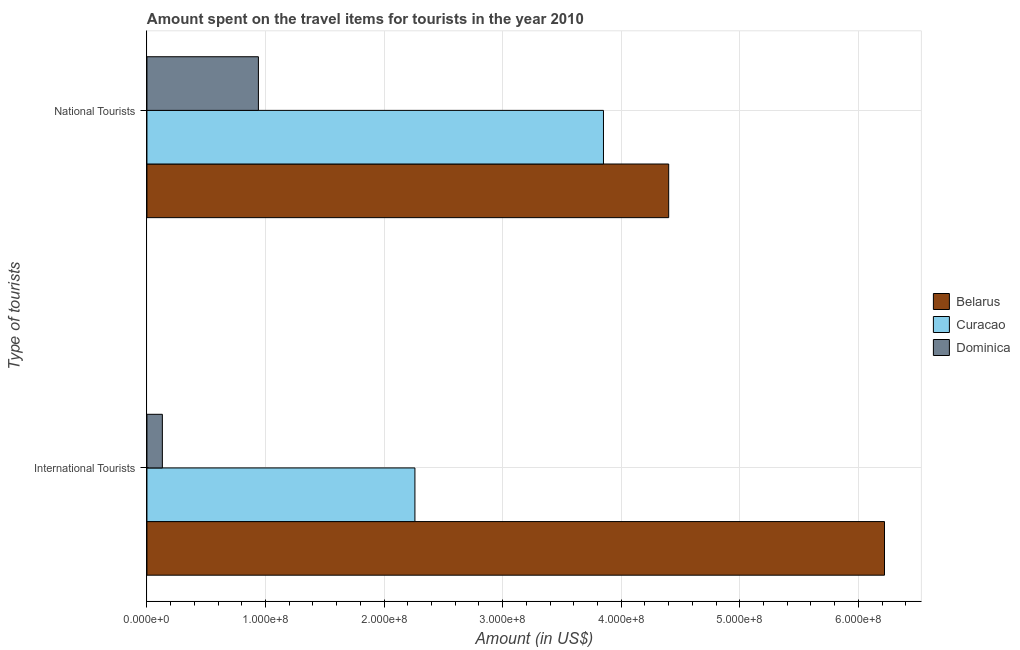Are the number of bars per tick equal to the number of legend labels?
Your answer should be compact. Yes. How many bars are there on the 2nd tick from the top?
Your answer should be very brief. 3. How many bars are there on the 2nd tick from the bottom?
Make the answer very short. 3. What is the label of the 2nd group of bars from the top?
Your answer should be compact. International Tourists. What is the amount spent on travel items of international tourists in Dominica?
Keep it short and to the point. 1.30e+07. Across all countries, what is the maximum amount spent on travel items of international tourists?
Provide a succinct answer. 6.22e+08. Across all countries, what is the minimum amount spent on travel items of national tourists?
Offer a very short reply. 9.40e+07. In which country was the amount spent on travel items of national tourists maximum?
Offer a terse response. Belarus. In which country was the amount spent on travel items of international tourists minimum?
Keep it short and to the point. Dominica. What is the total amount spent on travel items of national tourists in the graph?
Make the answer very short. 9.19e+08. What is the difference between the amount spent on travel items of national tourists in Curacao and that in Dominica?
Offer a very short reply. 2.91e+08. What is the difference between the amount spent on travel items of international tourists in Belarus and the amount spent on travel items of national tourists in Curacao?
Make the answer very short. 2.37e+08. What is the average amount spent on travel items of national tourists per country?
Ensure brevity in your answer.  3.06e+08. What is the difference between the amount spent on travel items of national tourists and amount spent on travel items of international tourists in Belarus?
Give a very brief answer. -1.82e+08. What is the ratio of the amount spent on travel items of international tourists in Dominica to that in Curacao?
Keep it short and to the point. 0.06. Is the amount spent on travel items of international tourists in Dominica less than that in Belarus?
Make the answer very short. Yes. In how many countries, is the amount spent on travel items of international tourists greater than the average amount spent on travel items of international tourists taken over all countries?
Offer a terse response. 1. What does the 1st bar from the top in National Tourists represents?
Offer a terse response. Dominica. What does the 1st bar from the bottom in National Tourists represents?
Give a very brief answer. Belarus. What is the difference between two consecutive major ticks on the X-axis?
Keep it short and to the point. 1.00e+08. Does the graph contain any zero values?
Your answer should be very brief. No. Does the graph contain grids?
Offer a very short reply. Yes. How are the legend labels stacked?
Give a very brief answer. Vertical. What is the title of the graph?
Ensure brevity in your answer.  Amount spent on the travel items for tourists in the year 2010. What is the label or title of the Y-axis?
Provide a succinct answer. Type of tourists. What is the Amount (in US$) in Belarus in International Tourists?
Your response must be concise. 6.22e+08. What is the Amount (in US$) of Curacao in International Tourists?
Your answer should be very brief. 2.26e+08. What is the Amount (in US$) in Dominica in International Tourists?
Your response must be concise. 1.30e+07. What is the Amount (in US$) in Belarus in National Tourists?
Provide a succinct answer. 4.40e+08. What is the Amount (in US$) of Curacao in National Tourists?
Make the answer very short. 3.85e+08. What is the Amount (in US$) in Dominica in National Tourists?
Your response must be concise. 9.40e+07. Across all Type of tourists, what is the maximum Amount (in US$) in Belarus?
Keep it short and to the point. 6.22e+08. Across all Type of tourists, what is the maximum Amount (in US$) in Curacao?
Your answer should be very brief. 3.85e+08. Across all Type of tourists, what is the maximum Amount (in US$) of Dominica?
Offer a very short reply. 9.40e+07. Across all Type of tourists, what is the minimum Amount (in US$) of Belarus?
Your answer should be compact. 4.40e+08. Across all Type of tourists, what is the minimum Amount (in US$) in Curacao?
Offer a terse response. 2.26e+08. Across all Type of tourists, what is the minimum Amount (in US$) of Dominica?
Ensure brevity in your answer.  1.30e+07. What is the total Amount (in US$) in Belarus in the graph?
Provide a short and direct response. 1.06e+09. What is the total Amount (in US$) in Curacao in the graph?
Keep it short and to the point. 6.11e+08. What is the total Amount (in US$) of Dominica in the graph?
Your answer should be very brief. 1.07e+08. What is the difference between the Amount (in US$) of Belarus in International Tourists and that in National Tourists?
Give a very brief answer. 1.82e+08. What is the difference between the Amount (in US$) of Curacao in International Tourists and that in National Tourists?
Offer a terse response. -1.59e+08. What is the difference between the Amount (in US$) in Dominica in International Tourists and that in National Tourists?
Give a very brief answer. -8.10e+07. What is the difference between the Amount (in US$) of Belarus in International Tourists and the Amount (in US$) of Curacao in National Tourists?
Ensure brevity in your answer.  2.37e+08. What is the difference between the Amount (in US$) of Belarus in International Tourists and the Amount (in US$) of Dominica in National Tourists?
Keep it short and to the point. 5.28e+08. What is the difference between the Amount (in US$) of Curacao in International Tourists and the Amount (in US$) of Dominica in National Tourists?
Provide a succinct answer. 1.32e+08. What is the average Amount (in US$) of Belarus per Type of tourists?
Your answer should be very brief. 5.31e+08. What is the average Amount (in US$) of Curacao per Type of tourists?
Provide a succinct answer. 3.06e+08. What is the average Amount (in US$) of Dominica per Type of tourists?
Give a very brief answer. 5.35e+07. What is the difference between the Amount (in US$) of Belarus and Amount (in US$) of Curacao in International Tourists?
Your answer should be very brief. 3.96e+08. What is the difference between the Amount (in US$) of Belarus and Amount (in US$) of Dominica in International Tourists?
Ensure brevity in your answer.  6.09e+08. What is the difference between the Amount (in US$) of Curacao and Amount (in US$) of Dominica in International Tourists?
Your answer should be very brief. 2.13e+08. What is the difference between the Amount (in US$) of Belarus and Amount (in US$) of Curacao in National Tourists?
Offer a very short reply. 5.50e+07. What is the difference between the Amount (in US$) in Belarus and Amount (in US$) in Dominica in National Tourists?
Make the answer very short. 3.46e+08. What is the difference between the Amount (in US$) in Curacao and Amount (in US$) in Dominica in National Tourists?
Your answer should be very brief. 2.91e+08. What is the ratio of the Amount (in US$) of Belarus in International Tourists to that in National Tourists?
Provide a short and direct response. 1.41. What is the ratio of the Amount (in US$) in Curacao in International Tourists to that in National Tourists?
Give a very brief answer. 0.59. What is the ratio of the Amount (in US$) in Dominica in International Tourists to that in National Tourists?
Keep it short and to the point. 0.14. What is the difference between the highest and the second highest Amount (in US$) in Belarus?
Make the answer very short. 1.82e+08. What is the difference between the highest and the second highest Amount (in US$) in Curacao?
Give a very brief answer. 1.59e+08. What is the difference between the highest and the second highest Amount (in US$) of Dominica?
Your answer should be compact. 8.10e+07. What is the difference between the highest and the lowest Amount (in US$) of Belarus?
Your response must be concise. 1.82e+08. What is the difference between the highest and the lowest Amount (in US$) in Curacao?
Your response must be concise. 1.59e+08. What is the difference between the highest and the lowest Amount (in US$) of Dominica?
Provide a succinct answer. 8.10e+07. 